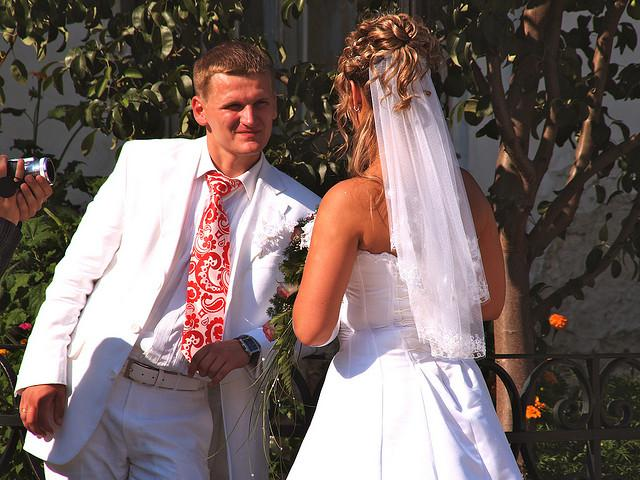What life event are they in the middle of celebrating? wedding 